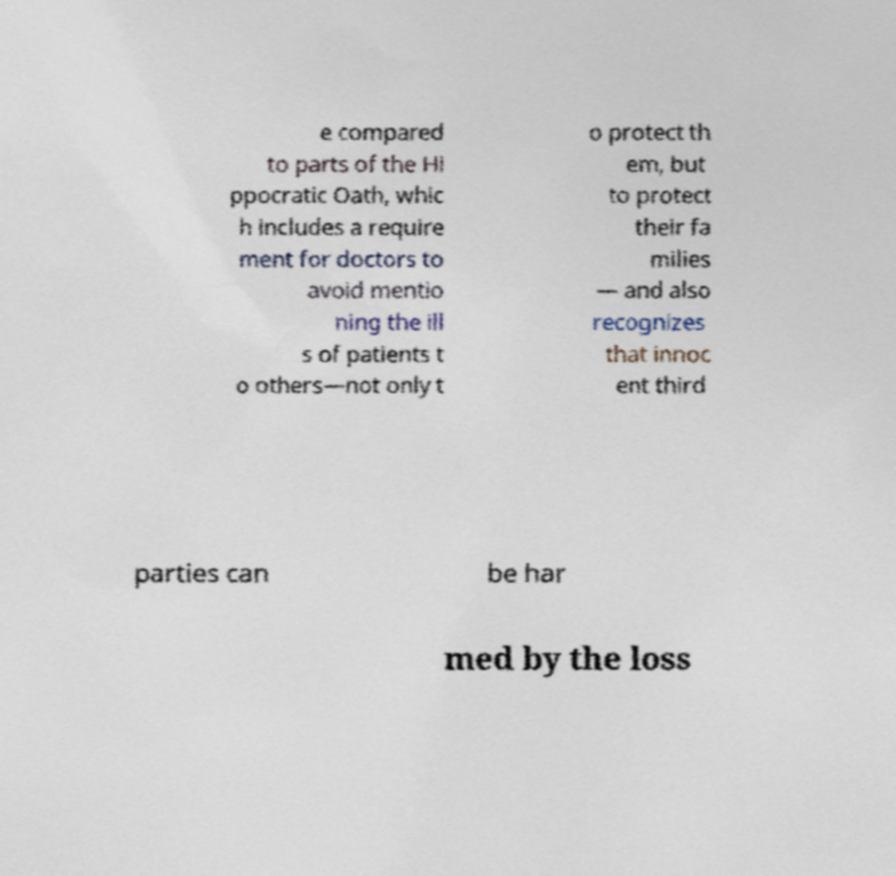Can you read and provide the text displayed in the image?This photo seems to have some interesting text. Can you extract and type it out for me? e compared to parts of the Hi ppocratic Oath, whic h includes a require ment for doctors to avoid mentio ning the ill s of patients t o others—not only t o protect th em, but to protect their fa milies — and also recognizes that innoc ent third parties can be har med by the loss 